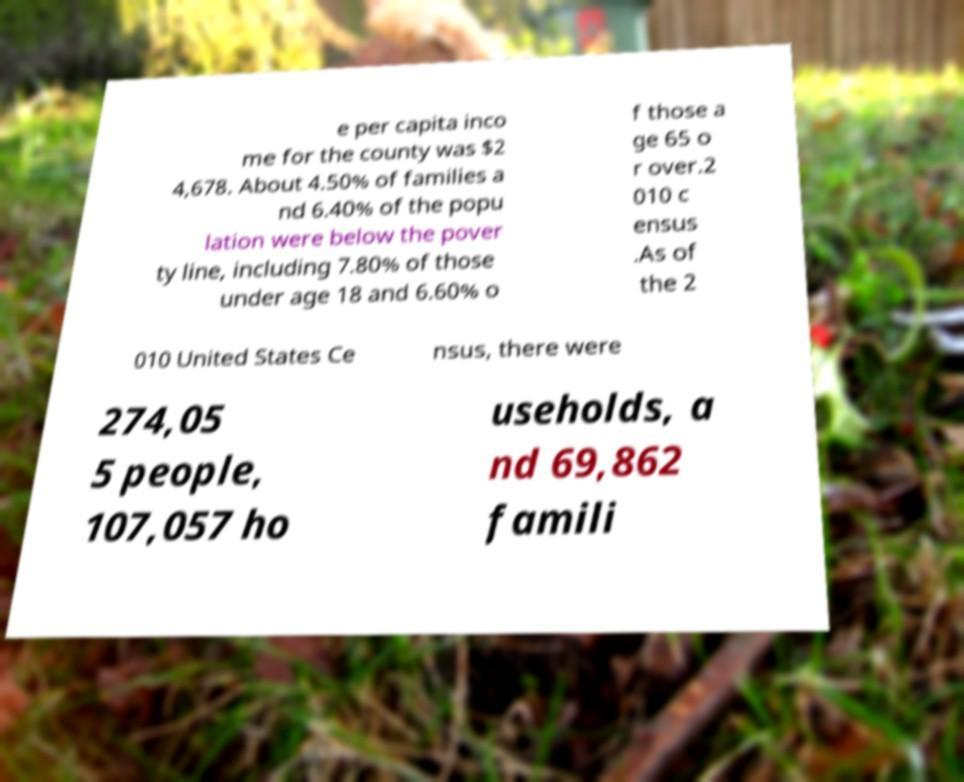There's text embedded in this image that I need extracted. Can you transcribe it verbatim? e per capita inco me for the county was $2 4,678. About 4.50% of families a nd 6.40% of the popu lation were below the pover ty line, including 7.80% of those under age 18 and 6.60% o f those a ge 65 o r over.2 010 c ensus .As of the 2 010 United States Ce nsus, there were 274,05 5 people, 107,057 ho useholds, a nd 69,862 famili 